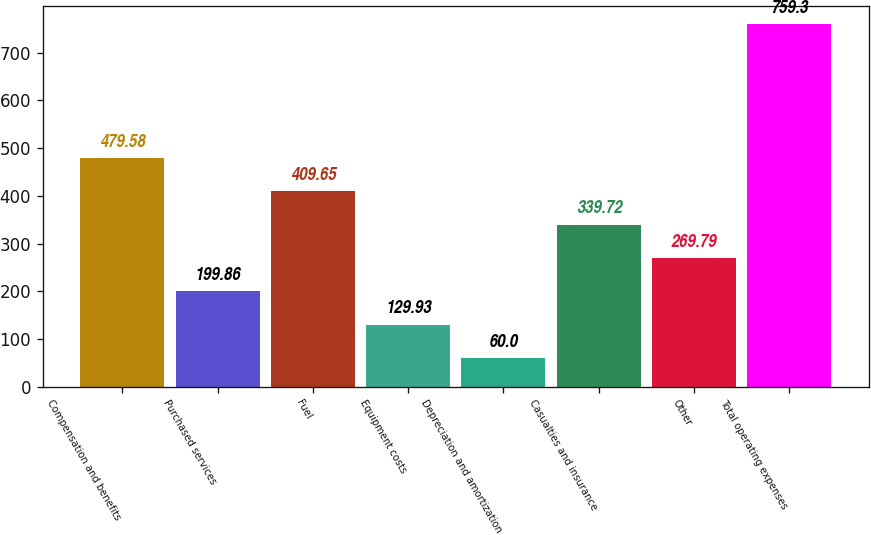Convert chart. <chart><loc_0><loc_0><loc_500><loc_500><bar_chart><fcel>Compensation and benefits<fcel>Purchased services<fcel>Fuel<fcel>Equipment costs<fcel>Depreciation and amortization<fcel>Casualties and insurance<fcel>Other<fcel>Total operating expenses<nl><fcel>479.58<fcel>199.86<fcel>409.65<fcel>129.93<fcel>60<fcel>339.72<fcel>269.79<fcel>759.3<nl></chart> 